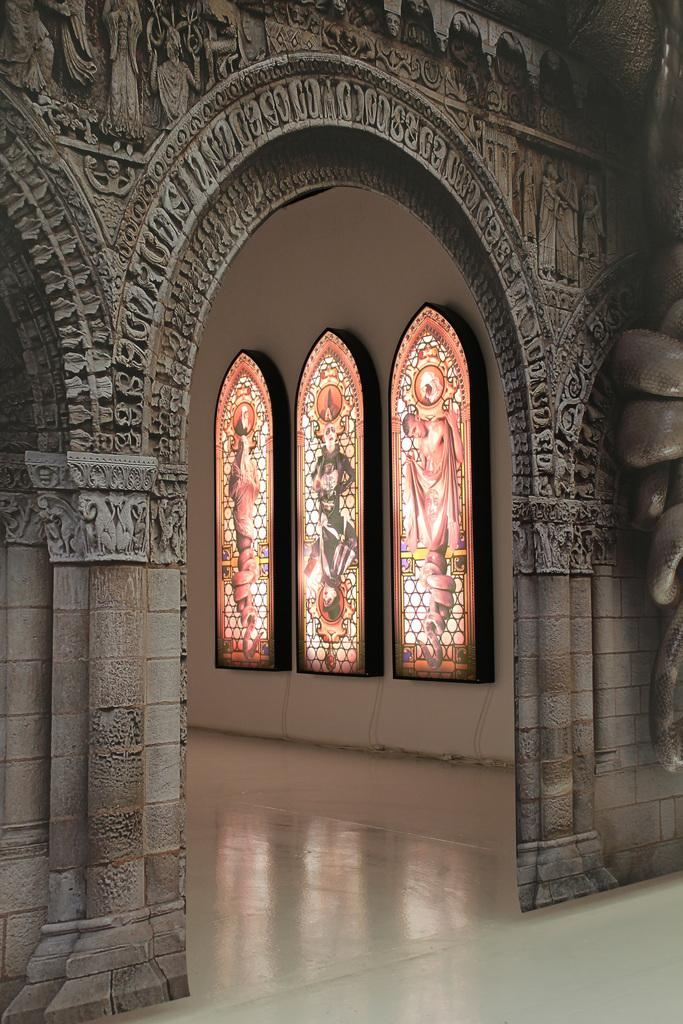What type of location is depicted in the image? The image is an inside view of a house. What architectural feature can be seen in the image? There is an arch with art in the image. What part of the house is visible at the bottom of the image? The floor is visible at the bottom of the image. What can be seen on the wall in the image? There are decorative items on a white wall in the image. What type of breakfast is being prepared in the image? There is no indication of breakfast or any food preparation in the image. How does the caretaker maintain balance while cleaning the art on the arch? There is no caretaker or cleaning activity depicted in the image. 